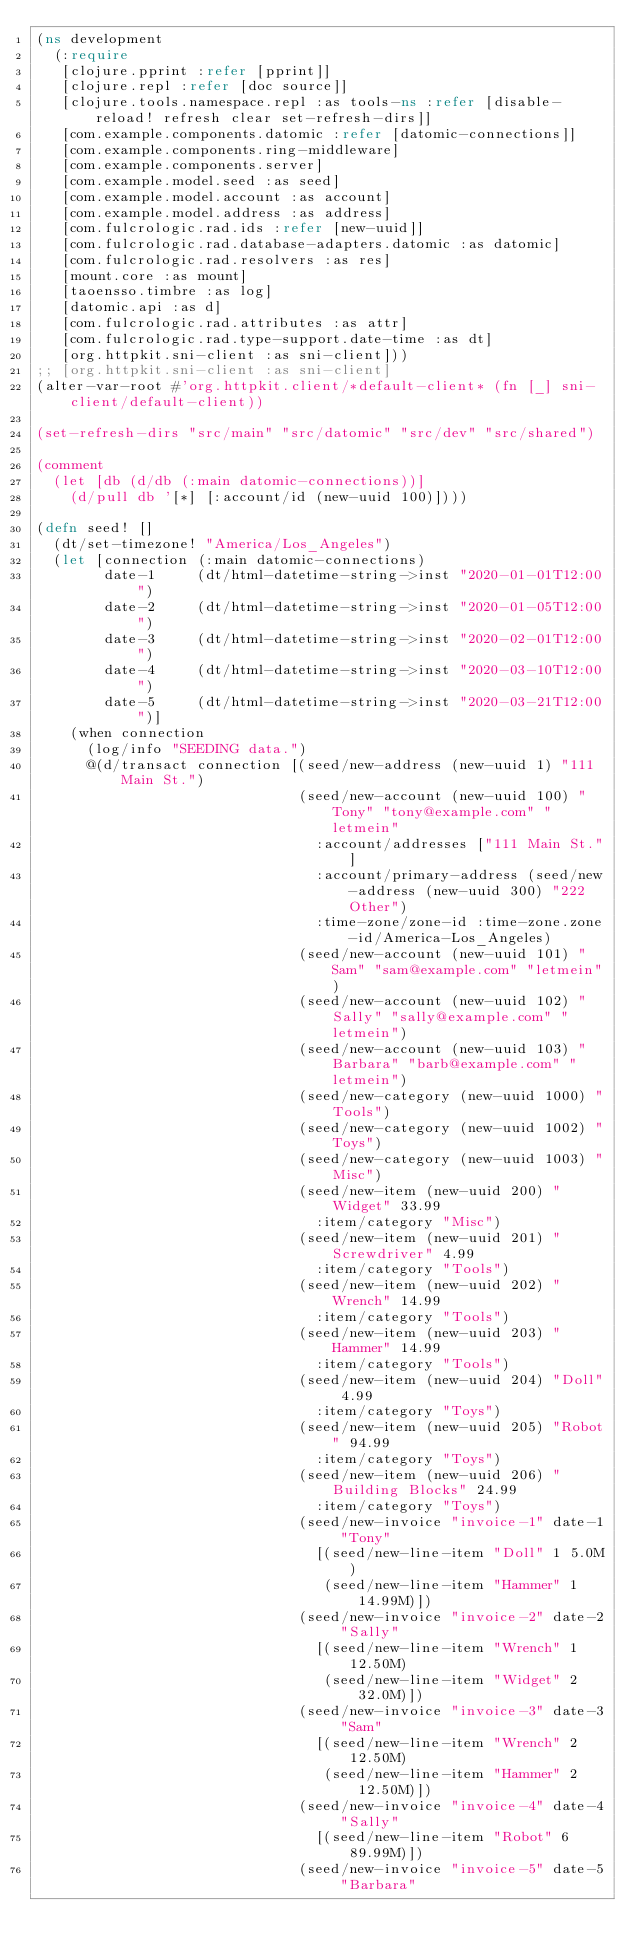Convert code to text. <code><loc_0><loc_0><loc_500><loc_500><_Clojure_>(ns development
  (:require
   [clojure.pprint :refer [pprint]]
   [clojure.repl :refer [doc source]]
   [clojure.tools.namespace.repl :as tools-ns :refer [disable-reload! refresh clear set-refresh-dirs]]
   [com.example.components.datomic :refer [datomic-connections]]
   [com.example.components.ring-middleware]
   [com.example.components.server]
   [com.example.model.seed :as seed]
   [com.example.model.account :as account]
   [com.example.model.address :as address]
   [com.fulcrologic.rad.ids :refer [new-uuid]]
   [com.fulcrologic.rad.database-adapters.datomic :as datomic]
   [com.fulcrologic.rad.resolvers :as res]
   [mount.core :as mount]
   [taoensso.timbre :as log]
   [datomic.api :as d]
   [com.fulcrologic.rad.attributes :as attr]
   [com.fulcrologic.rad.type-support.date-time :as dt]
   [org.httpkit.sni-client :as sni-client]))
;; [org.httpkit.sni-client :as sni-client]
(alter-var-root #'org.httpkit.client/*default-client* (fn [_] sni-client/default-client))

(set-refresh-dirs "src/main" "src/datomic" "src/dev" "src/shared")

(comment
  (let [db (d/db (:main datomic-connections))]
    (d/pull db '[*] [:account/id (new-uuid 100)])))

(defn seed! []
  (dt/set-timezone! "America/Los_Angeles")
  (let [connection (:main datomic-connections)
        date-1     (dt/html-datetime-string->inst "2020-01-01T12:00")
        date-2     (dt/html-datetime-string->inst "2020-01-05T12:00")
        date-3     (dt/html-datetime-string->inst "2020-02-01T12:00")
        date-4     (dt/html-datetime-string->inst "2020-03-10T12:00")
        date-5     (dt/html-datetime-string->inst "2020-03-21T12:00")]
    (when connection
      (log/info "SEEDING data.")
      @(d/transact connection [(seed/new-address (new-uuid 1) "111 Main St.")
                               (seed/new-account (new-uuid 100) "Tony" "tony@example.com" "letmein"
                                 :account/addresses ["111 Main St."]
                                 :account/primary-address (seed/new-address (new-uuid 300) "222 Other")
                                 :time-zone/zone-id :time-zone.zone-id/America-Los_Angeles)
                               (seed/new-account (new-uuid 101) "Sam" "sam@example.com" "letmein")
                               (seed/new-account (new-uuid 102) "Sally" "sally@example.com" "letmein")
                               (seed/new-account (new-uuid 103) "Barbara" "barb@example.com" "letmein")
                               (seed/new-category (new-uuid 1000) "Tools")
                               (seed/new-category (new-uuid 1002) "Toys")
                               (seed/new-category (new-uuid 1003) "Misc")
                               (seed/new-item (new-uuid 200) "Widget" 33.99
                                 :item/category "Misc")
                               (seed/new-item (new-uuid 201) "Screwdriver" 4.99
                                 :item/category "Tools")
                               (seed/new-item (new-uuid 202) "Wrench" 14.99
                                 :item/category "Tools")
                               (seed/new-item (new-uuid 203) "Hammer" 14.99
                                 :item/category "Tools")
                               (seed/new-item (new-uuid 204) "Doll" 4.99
                                 :item/category "Toys")
                               (seed/new-item (new-uuid 205) "Robot" 94.99
                                 :item/category "Toys")
                               (seed/new-item (new-uuid 206) "Building Blocks" 24.99
                                 :item/category "Toys")
                               (seed/new-invoice "invoice-1" date-1 "Tony"
                                 [(seed/new-line-item "Doll" 1 5.0M)
                                  (seed/new-line-item "Hammer" 1 14.99M)])
                               (seed/new-invoice "invoice-2" date-2 "Sally"
                                 [(seed/new-line-item "Wrench" 1 12.50M)
                                  (seed/new-line-item "Widget" 2 32.0M)])
                               (seed/new-invoice "invoice-3" date-3 "Sam"
                                 [(seed/new-line-item "Wrench" 2 12.50M)
                                  (seed/new-line-item "Hammer" 2 12.50M)])
                               (seed/new-invoice "invoice-4" date-4 "Sally"
                                 [(seed/new-line-item "Robot" 6 89.99M)])
                               (seed/new-invoice "invoice-5" date-5 "Barbara"</code> 